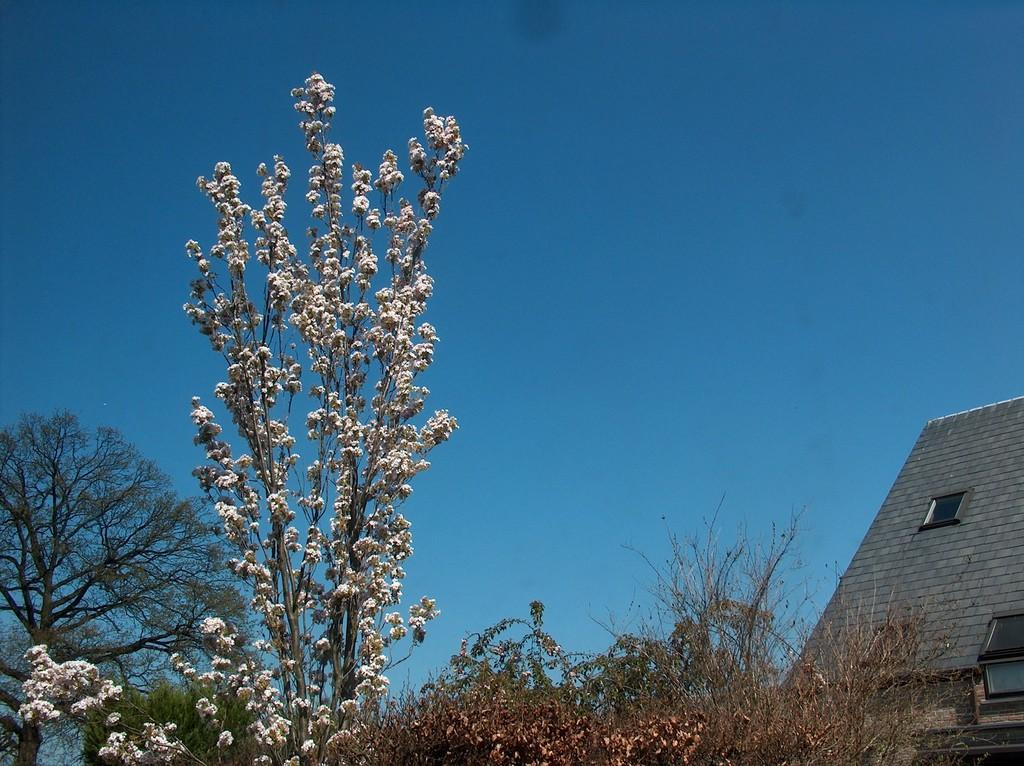What type of vegetation is present in the image? The image contains trees. What can be seen in the front of the image? There are white-colored flowers in the front of the image. Where is the building located in the image? The building is on the right side of the image. What feature of the building is visible in the image? The building has a window. What is visible at the top of the image? The sky is visible at the top of the image. Can you see any ghosts interacting with the flowers in the image? There are no ghosts present in the image. What type of bee can be seen pollinating the white flowers in the image? There are no bees present in the image; it only shows white flowers and trees. 